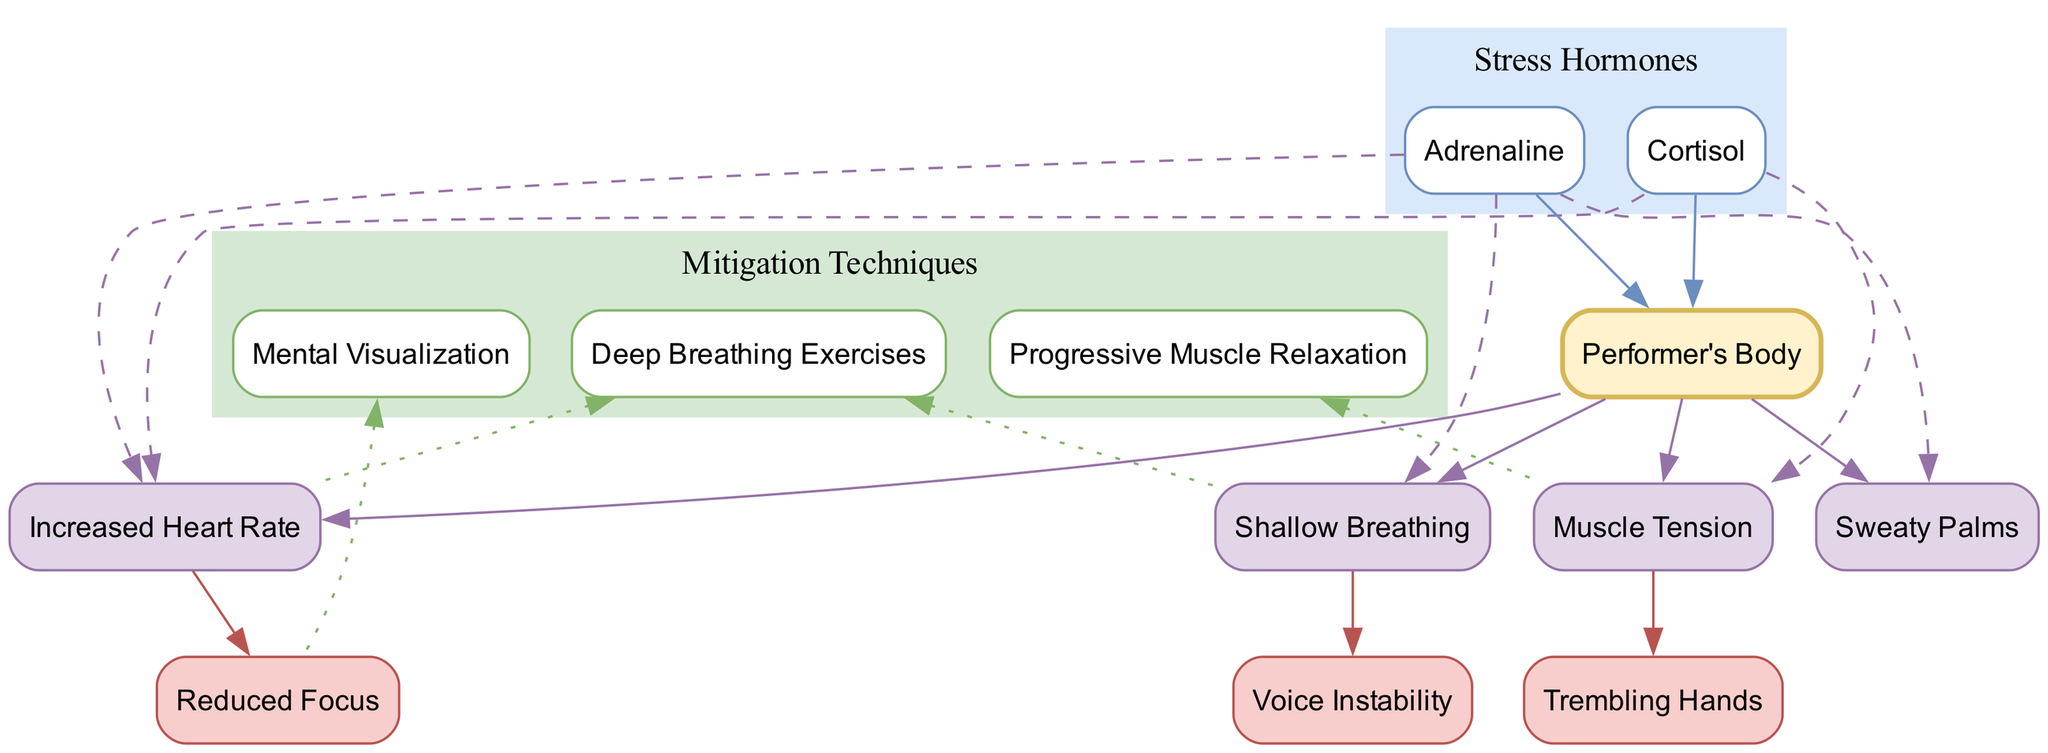What are the stress hormones affecting the performer's body? The diagram indicates that the stress hormones impacting the performer's body are listed under the "Stress Hormones" section. It lists "Cortisol" and "Adrenaline."
Answer: Cortisol, Adrenaline How many physiological effects are connected to cortisol? By examining the "Physiological Effects" section in the diagram, it shows two effects ("Increased Heart Rate" and "Muscle Tension") that are connected to cortisol.
Answer: 2 Which physiological effect is linked to both stress hormones? Looking at the "Physiological Effects" section, "Increased Heart Rate" is connected to both cortisol and adrenaline, making it the sole effect linked to both hormones.
Answer: Increased Heart Rate What is the performance impact associated with muscle tension? The diagram shows one performance impact ("Trembling Hands") linked to "Muscle Tension" in the "Performance Impacts" section, indicating that muscle tension causes trembling hands.
Answer: Trembling Hands Which mitigation technique targets shallow breathing? In the "Mitigation Techniques" section of the diagram, "Deep Breathing Exercises" specifically targets shallow breathing, shown by an edge connecting the technique to the effect.
Answer: Deep Breathing Exercises How many performance impacts are shown in the diagram? The "Performance Impacts" section of the diagram lists three impacts ("Trembling Hands," "Voice Instability," and "Reduced Focus"), so a count gives us the number of performance impacts.
Answer: 3 What is the relationship between shallow breathing and voice instability? According to the diagram, "Shallow Breathing" leads to "Voice Instability," indicated by a direct connection in the flow of effects within the diagram.
Answer: Shallow Breathing leads to Voice Instability Which mitigation technique addresses muscle tension? The diagram indicates that "Progressive Muscle Relaxation" is the technique specifically connected to mitigating "Muscle Tension," as shown in the "Mitigation Techniques."
Answer: Progressive Muscle Relaxation What effect does increased heart rate have on performance? The diagram demonstrates that "Increased Heart Rate" is connected to "Reduced Focus," indicating that higher heart rates negatively impact focus during performance.
Answer: Reduced Focus 